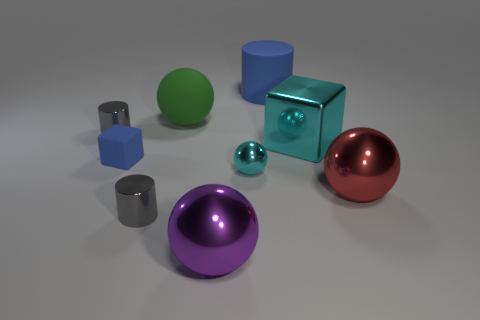What number of purple objects are either large metal spheres or matte objects?
Make the answer very short. 1. What number of metallic blocks are in front of the big sphere that is on the right side of the blue rubber cylinder?
Your response must be concise. 0. Are there any other things that are the same color as the small rubber object?
Your answer should be compact. Yes. What shape is the purple thing that is the same material as the small cyan ball?
Give a very brief answer. Sphere. Does the tiny rubber block have the same color as the big matte cylinder?
Provide a short and direct response. Yes. Does the gray cylinder in front of the cyan block have the same material as the ball to the left of the big purple shiny sphere?
Keep it short and to the point. No. How many objects are either small cyan metal spheres or big balls on the left side of the rubber cylinder?
Give a very brief answer. 3. Are there any other things that have the same material as the green thing?
Your response must be concise. Yes. What shape is the thing that is the same color as the tiny block?
Give a very brief answer. Cylinder. What is the material of the tiny blue thing?
Make the answer very short. Rubber. 